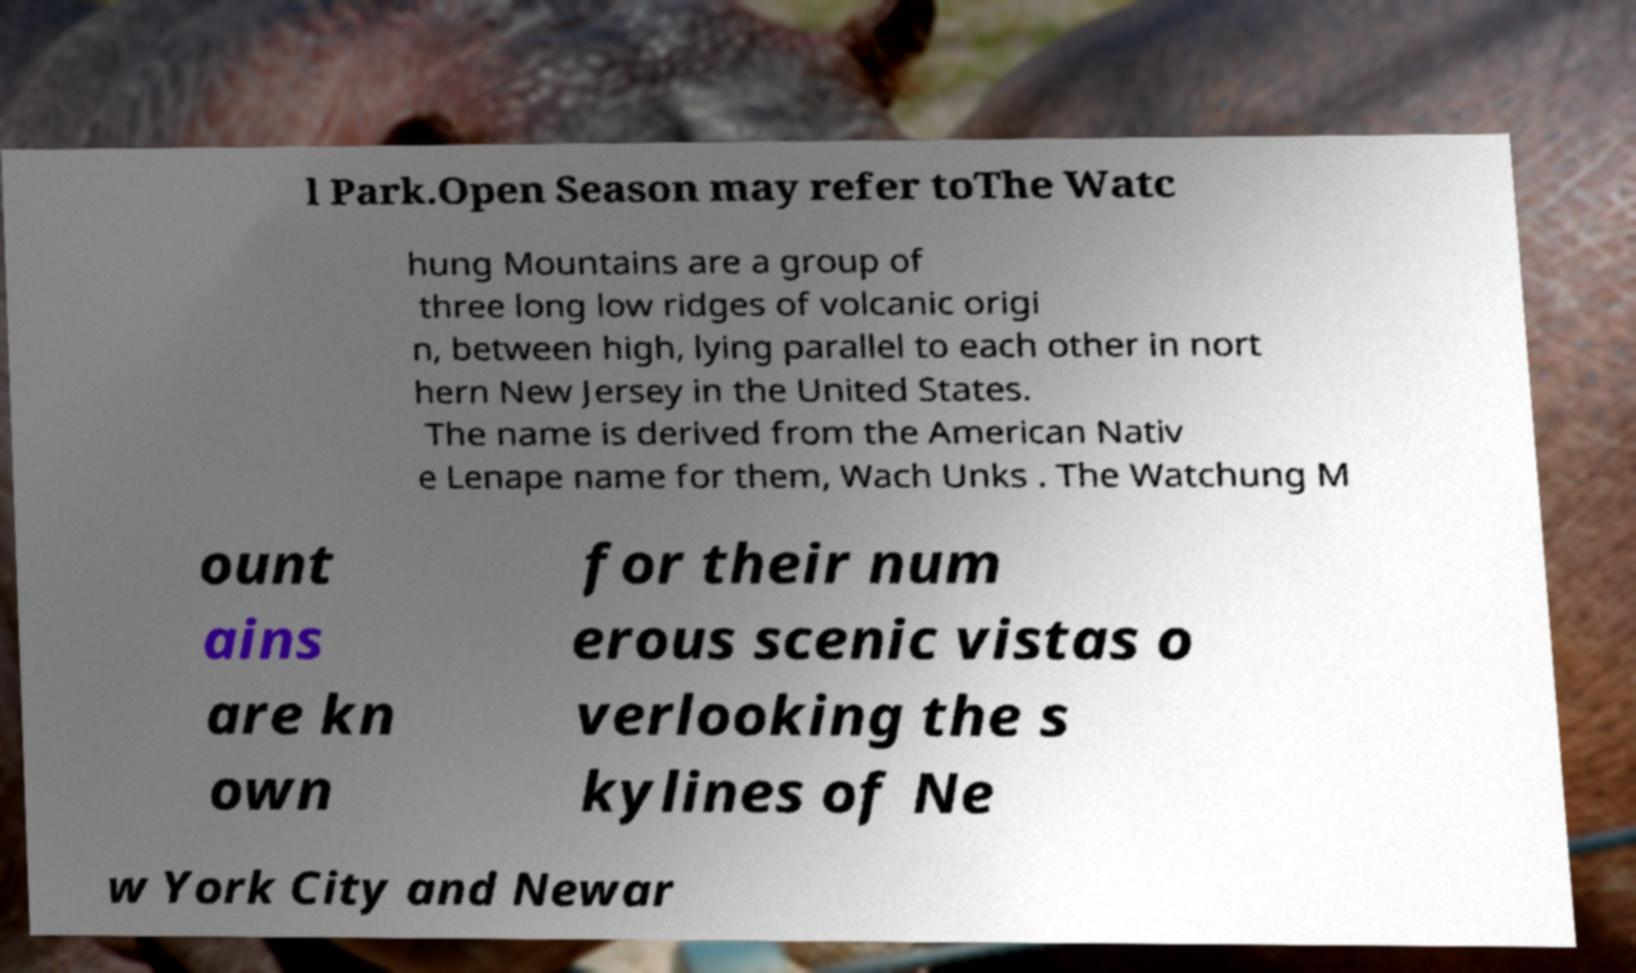Can you read and provide the text displayed in the image?This photo seems to have some interesting text. Can you extract and type it out for me? l Park.Open Season may refer toThe Watc hung Mountains are a group of three long low ridges of volcanic origi n, between high, lying parallel to each other in nort hern New Jersey in the United States. The name is derived from the American Nativ e Lenape name for them, Wach Unks . The Watchung M ount ains are kn own for their num erous scenic vistas o verlooking the s kylines of Ne w York City and Newar 